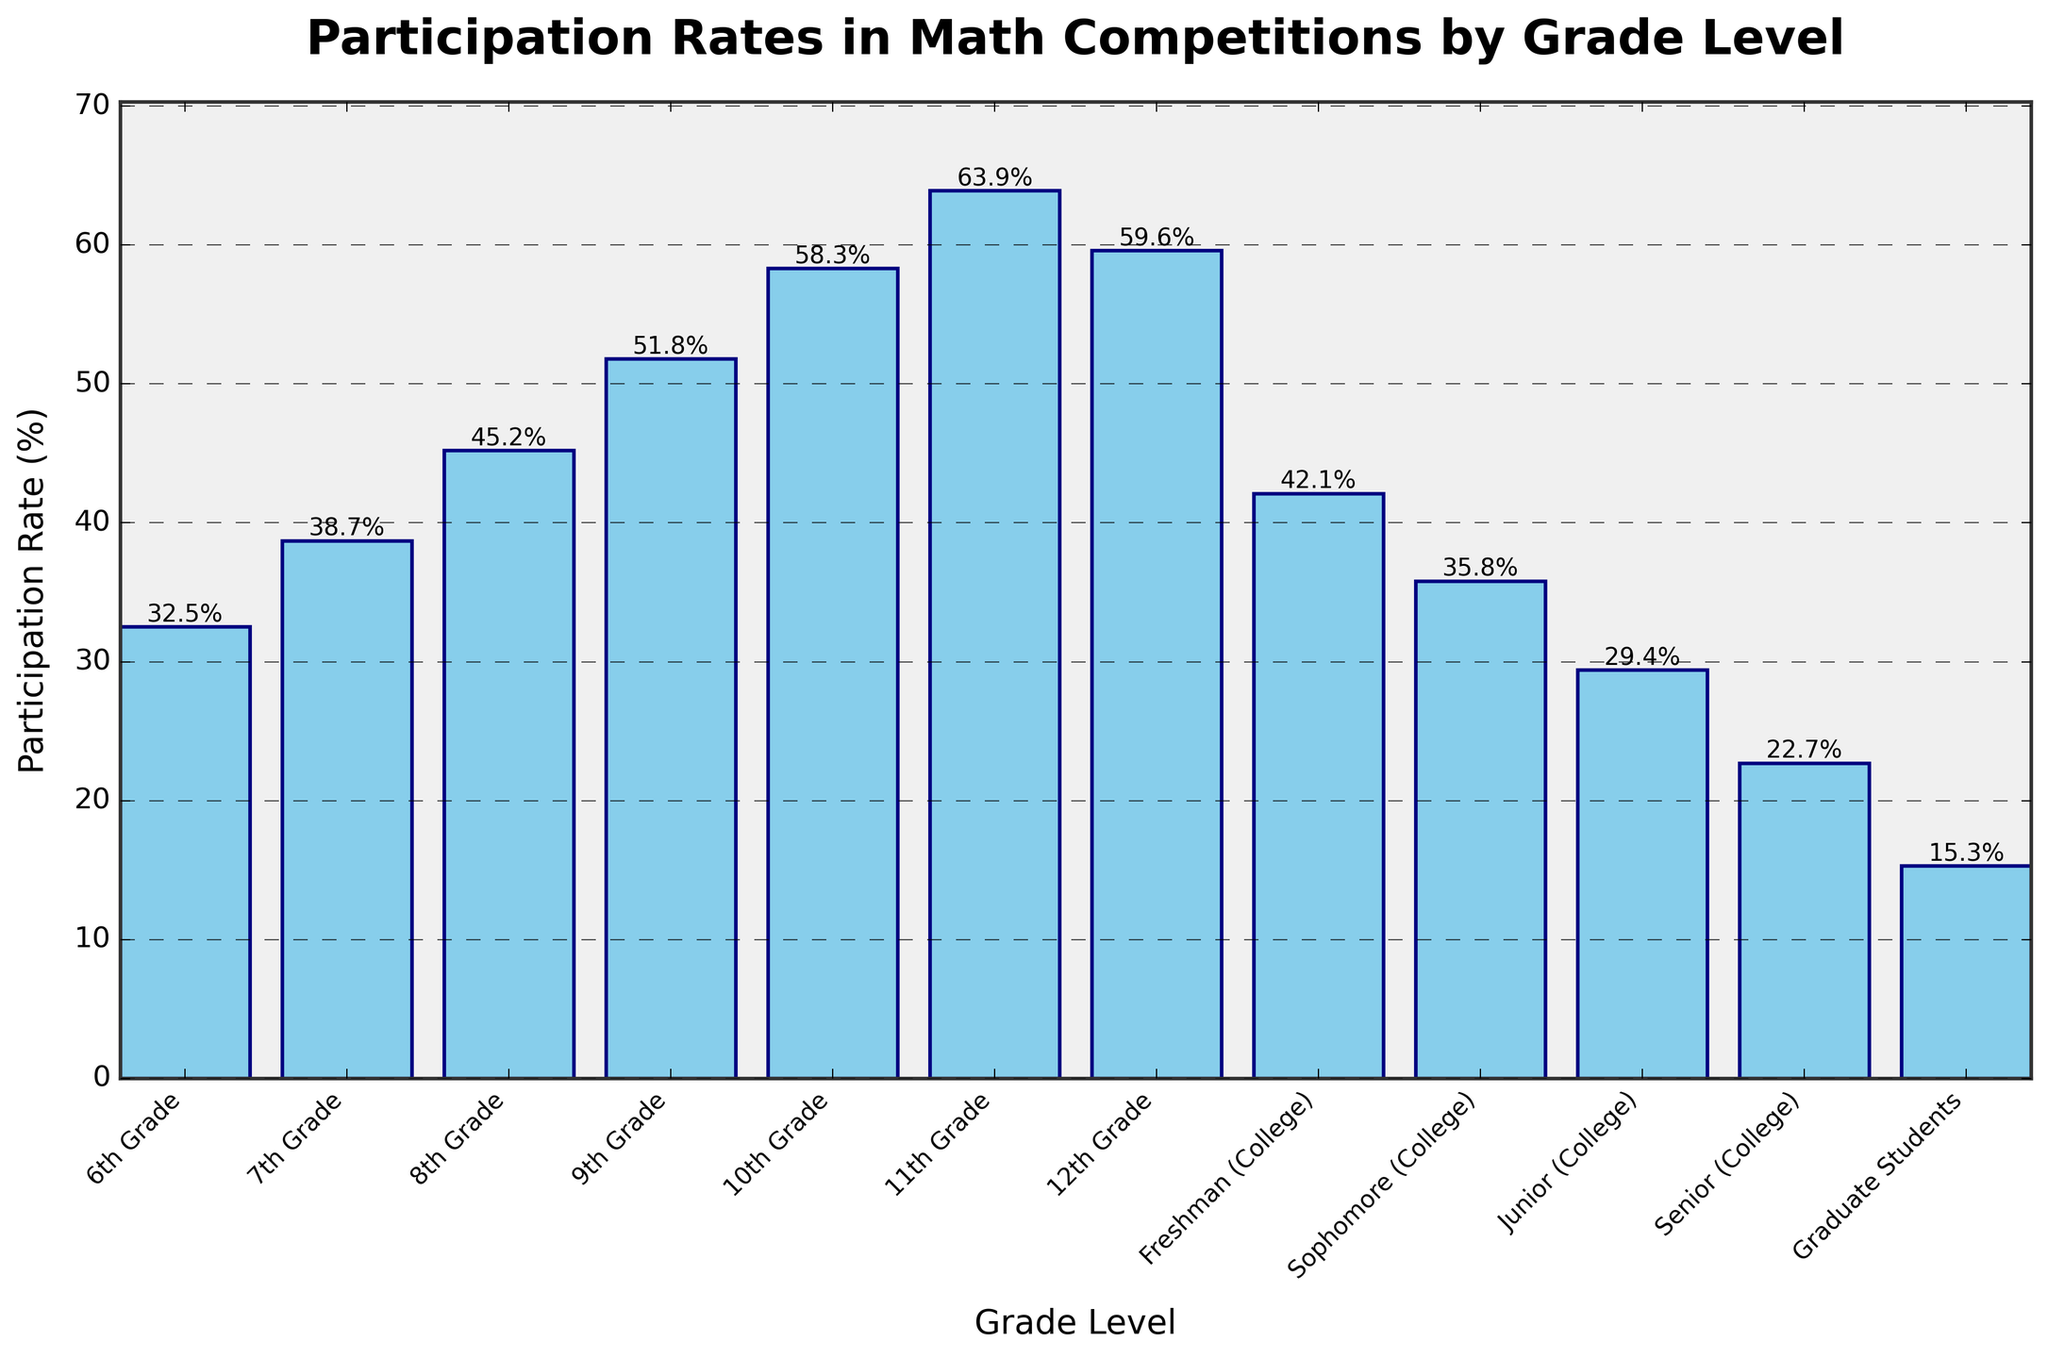What's the participation rate difference between 12th Grade and Freshman (College)? To find the difference, subtract the participation rate of Freshman (College) from the participation rate of 12th Grade. This is 59.6% - 42.1%.
Answer: 17.5% What is the median participation rate across all grade levels? First, list all the participation rates in ascending order: 15.3, 22.7, 29.4, 32.5, 35.8, 38.7, 42.1, 45.2, 51.8, 58.3, 59.6, 63.9. Since there are 12 data points, the median is the average of the 6th and 7th values, which are 38.7 and 42.1. Thus, the median is (38.7 + 42.1) / 2.
Answer: 40.4% How many grade levels have a participation rate higher than 50%? Visually identify the bars that are taller than 50%. These are: 9th Grade, 10th Grade, 11th Grade, and 12th Grade.
Answer: 4 Which grade level has the lowest participation rate? By comparing the heights of all the bars, the shortest bar corresponds to Graduate Students.
Answer: Graduate Students What is the participation rate in 11th Grade compared to 8th Grade? To find this, compare the heights of the bars for 11th Grade and 8th Grade. The participation rate for 11th Grade is 63.9% and for 8th Grade is 45.2%. Determine which is higher.
Answer: 11th Grade is higher What is the average participation rate for Middle School grades (6th to 8th)? Add the participation rates for 6th, 7th, and 8th Grades: 32.5 + 38.7 + 45.2 = 116.4. Divide by the number of grades, which is 3. The average is 116.4 / 3.
Answer: 38.8% How does the participation rate trend from 6th Grade to 12th Grade and then decrease in College? Observe the increasing height of the bars from 6th Grade to 11th Grade, peaking at 11th, then slightly decreasing for 12th Grade, and significantly dropping in College years.
Answer: Increases then decreases Which two consecutive grade levels have the largest increase in participation rate? Calculate the differences between the participation rates for consecutive grades: 
7th - 6th: 38.7 - 32.5 = 6.2
8th - 7th: 45.2 - 38.7 = 6.5 
9th - 8th: 51.8 - 45.2 = 6.6
10th - 9th: 58.3 - 51.8 = 6.5
11th - 10th: 63.9 - 58.3 = 5.6
12th - 11th: 59.6 - 63.9 = -4.3
Find the maximum increase, which is 6.6 between 8th and 9th Grades.
Answer: 8th to 9th Grade What is the total participation rate for all high school (9th to 12th) grades? Add the participation rates of the 9th, 10th, 11th, and 12th Grades: 51.8 + 58.3 + 63.9 + 59.6 = 233.6%.
Answer: 233.6% Is there a consistent trend in participation rates across the College years? Observe the trend from Freshman to Graduate Students. The participation rates consistently decrease from Freshman (42.1%), Sophomore (35.8%), Junior (29.4%), Senior (22.7%), to Graduate Students (15.3%).
Answer: Yes, it decreases 